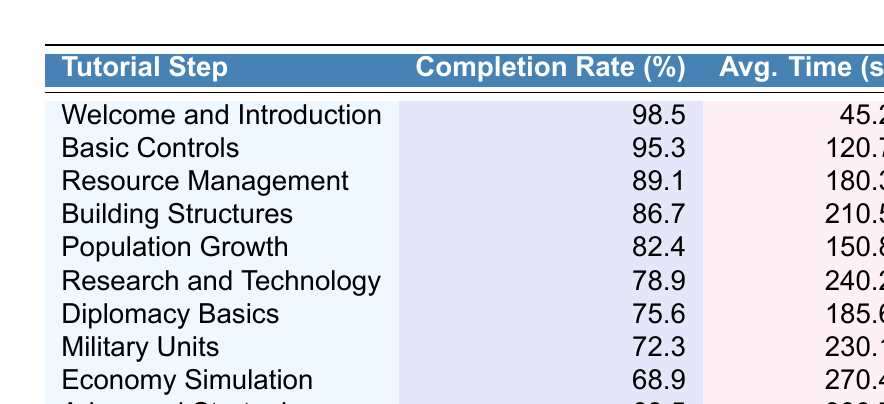What is the completion rate for the "Basic Controls" tutorial step? The table shows the completion rate for each tutorial step. For "Basic Controls," the completion rate listed is 95.3%.
Answer: 95.3% Which tutorial step has the lowest completion rate? By examining the completion rates for all tutorial steps in the table, "Advanced Strategies" has the lowest completion rate at 63.5%.
Answer: Advanced Strategies What is the average time spent on the "Population Growth" step? The table specifies the average time spent on each tutorial step. For "Population Growth," the average time is 150.8 seconds.
Answer: 150.8 seconds What is the difference in completion rates between "Research and Technology" and "Diplomacy Basics"? To find the difference, subtract the completion rate of "Diplomacy Basics" (75.6%) from "Research and Technology" (78.9%): 78.9 - 75.6 = 3.3%.
Answer: 3.3% What is the average completion rate across all tutorial steps? First, add up all the completion rates: 98.5 + 95.3 + 89.1 + 86.7 + 82.4 + 78.9 + 75.6 + 72.3 + 68.9 + 63.5 =  837.2%. Then divide the total by the number of steps, which is 10: 837.2 / 10 = 83.72%.
Answer: 83.72% Is the average time spent on "Military Units" longer than that for "Economic Simulation"? The average time for "Military Units" is 230.1 seconds, while for "Economic Simulation," it is 270.4 seconds. Since 230.1 is less than 270.4, the statement is false.
Answer: No Which tutorial steps have a completion rate above 80%? By reviewing the completion rates provided in the table, the steps with above 80% completion rates are "Welcome and Introduction," "Basic Controls," "Resource Management," "Building Structures," and "Population Growth."
Answer: 5 steps What is the total average time spent on all tutorial steps? Adding all average times: 45.2 + 120.7 + 180.3 + 210.5 + 150.8 + 240.2 + 185.6 + 230.1 + 270.4 + 300.7 = 1895.5 seconds.
Answer: 1895.5 seconds Which tutorial step requires the most time on average? By looking at the average time spent for each step, "Advanced Strategies" has the highest average time at 300.7 seconds.
Answer: Advanced Strategies How many steps have an average time spent of less than 200 seconds? From the data, the steps with an average time spent of less than 200 seconds are "Welcome and Introduction," "Basic Controls," and "Population Growth," summing up to 3 steps.
Answer: 3 steps 